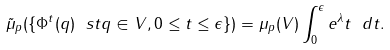Convert formula to latex. <formula><loc_0><loc_0><loc_500><loc_500>\tilde { \mu } _ { p } ( \{ \Phi ^ { t } ( q ) \ s t q \in V , 0 \leq t \leq \epsilon \} ) = \mu _ { p } ( V ) \int _ { 0 } ^ { \epsilon } e ^ { \lambda } t \ d t .</formula> 